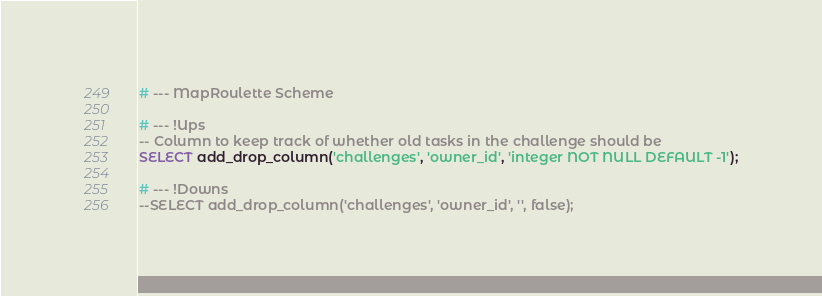Convert code to text. <code><loc_0><loc_0><loc_500><loc_500><_SQL_># --- MapRoulette Scheme

# --- !Ups
-- Column to keep track of whether old tasks in the challenge should be
SELECT add_drop_column('challenges', 'owner_id', 'integer NOT NULL DEFAULT -1');

# --- !Downs
--SELECT add_drop_column('challenges', 'owner_id', '', false);
</code> 